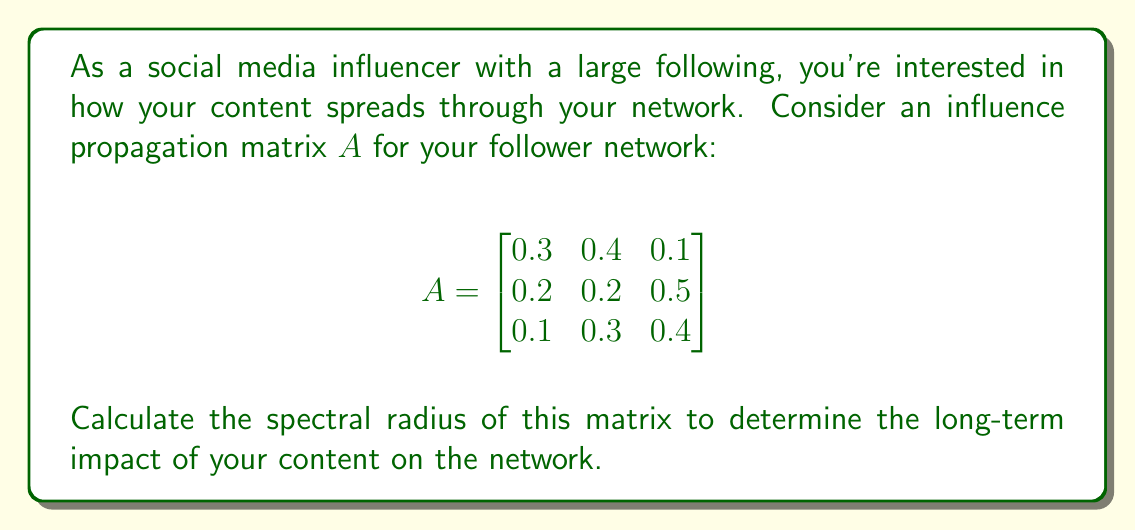Give your solution to this math problem. To find the spectral radius of matrix $A$, we need to follow these steps:

1) First, calculate the characteristic polynomial of $A$:
   $det(A - \lambda I) = 0$

   $$\begin{vmatrix}
   0.3-\lambda & 0.4 & 0.1 \\
   0.2 & 0.2-\lambda & 0.5 \\
   0.1 & 0.3 & 0.4-\lambda
   \end{vmatrix} = 0$$

2) Expand the determinant:
   $(0.3-\lambda)((0.2-\lambda)(0.4-\lambda) - 0.15) + 0.4(0.2(0.4-\lambda) - 0.05) + 0.1(0.2(0.3) - 0.5(0.2-\lambda)) = 0$

3) Simplify:
   $-\lambda^3 + 0.9\lambda^2 - 0.23\lambda + 0.018 = 0$

4) The roots of this polynomial are the eigenvalues of $A$. We can use a numerical method to find these roots:
   $\lambda_1 \approx 0.8054$
   $\lambda_2 \approx 0.0473 + 0.1211i$
   $\lambda_3 \approx 0.0473 - 0.1211i$

5) The spectral radius is the maximum absolute value of these eigenvalues:
   $\rho(A) = max(|\lambda_1|, |\lambda_2|, |\lambda_3|) = |\lambda_1| \approx 0.8054$

This spectral radius indicates that your influence in the network will grow over time if it's greater than 1, or decay if it's less than 1. In this case, it's less than 1, suggesting a decay in influence over multiple sharing cycles.
Answer: $\rho(A) \approx 0.8054$ 